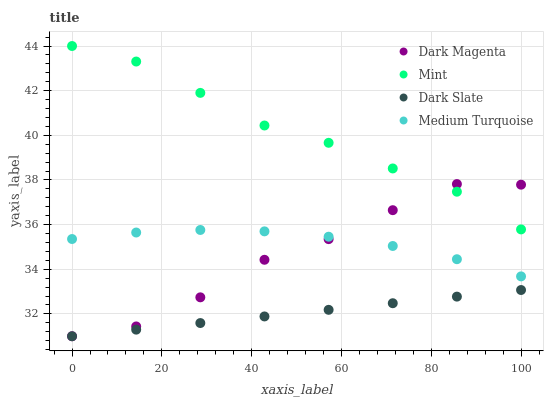Does Dark Slate have the minimum area under the curve?
Answer yes or no. Yes. Does Mint have the maximum area under the curve?
Answer yes or no. Yes. Does Dark Magenta have the minimum area under the curve?
Answer yes or no. No. Does Dark Magenta have the maximum area under the curve?
Answer yes or no. No. Is Dark Slate the smoothest?
Answer yes or no. Yes. Is Dark Magenta the roughest?
Answer yes or no. Yes. Is Mint the smoothest?
Answer yes or no. No. Is Mint the roughest?
Answer yes or no. No. Does Dark Slate have the lowest value?
Answer yes or no. Yes. Does Mint have the lowest value?
Answer yes or no. No. Does Mint have the highest value?
Answer yes or no. Yes. Does Dark Magenta have the highest value?
Answer yes or no. No. Is Medium Turquoise less than Mint?
Answer yes or no. Yes. Is Medium Turquoise greater than Dark Slate?
Answer yes or no. Yes. Does Dark Magenta intersect Mint?
Answer yes or no. Yes. Is Dark Magenta less than Mint?
Answer yes or no. No. Is Dark Magenta greater than Mint?
Answer yes or no. No. Does Medium Turquoise intersect Mint?
Answer yes or no. No. 